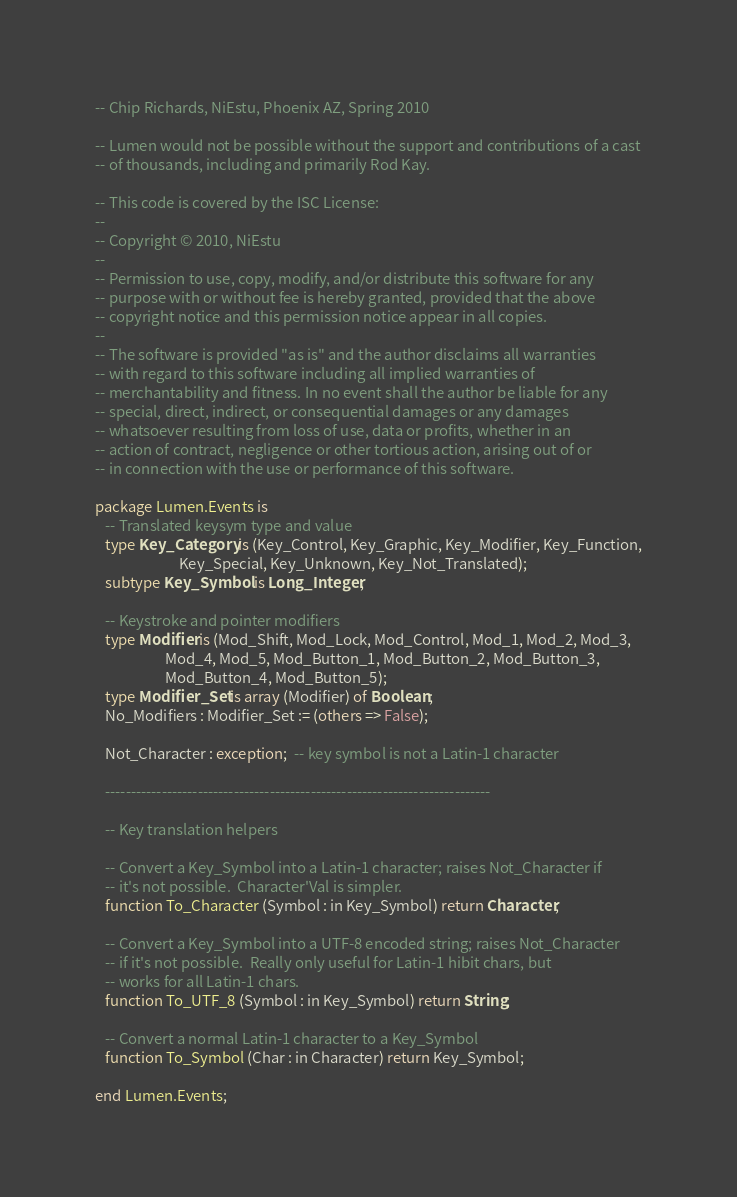Convert code to text. <code><loc_0><loc_0><loc_500><loc_500><_Ada_>
-- Chip Richards, NiEstu, Phoenix AZ, Spring 2010

-- Lumen would not be possible without the support and contributions of a cast
-- of thousands, including and primarily Rod Kay.

-- This code is covered by the ISC License:
--
-- Copyright © 2010, NiEstu
--
-- Permission to use, copy, modify, and/or distribute this software for any
-- purpose with or without fee is hereby granted, provided that the above
-- copyright notice and this permission notice appear in all copies.
--
-- The software is provided "as is" and the author disclaims all warranties
-- with regard to this software including all implied warranties of
-- merchantability and fitness. In no event shall the author be liable for any
-- special, direct, indirect, or consequential damages or any damages
-- whatsoever resulting from loss of use, data or profits, whether in an
-- action of contract, negligence or other tortious action, arising out of or
-- in connection with the use or performance of this software.

package Lumen.Events is
   -- Translated keysym type and value
   type Key_Category is (Key_Control, Key_Graphic, Key_Modifier, Key_Function,
                         Key_Special, Key_Unknown, Key_Not_Translated);
   subtype Key_Symbol is Long_Integer;

   -- Keystroke and pointer modifiers
   type Modifier is (Mod_Shift, Mod_Lock, Mod_Control, Mod_1, Mod_2, Mod_3,
                     Mod_4, Mod_5, Mod_Button_1, Mod_Button_2, Mod_Button_3,
                     Mod_Button_4, Mod_Button_5);
   type Modifier_Set is array (Modifier) of Boolean;
   No_Modifiers : Modifier_Set := (others => False);

   Not_Character : exception;  -- key symbol is not a Latin-1 character

   ---------------------------------------------------------------------------

   -- Key translation helpers

   -- Convert a Key_Symbol into a Latin-1 character; raises Not_Character if
   -- it's not possible.  Character'Val is simpler.
   function To_Character (Symbol : in Key_Symbol) return Character;

   -- Convert a Key_Symbol into a UTF-8 encoded string; raises Not_Character
   -- if it's not possible.  Really only useful for Latin-1 hibit chars, but
   -- works for all Latin-1 chars.
   function To_UTF_8 (Symbol : in Key_Symbol) return String;

   -- Convert a normal Latin-1 character to a Key_Symbol
   function To_Symbol (Char : in Character) return Key_Symbol;

end Lumen.Events;
</code> 